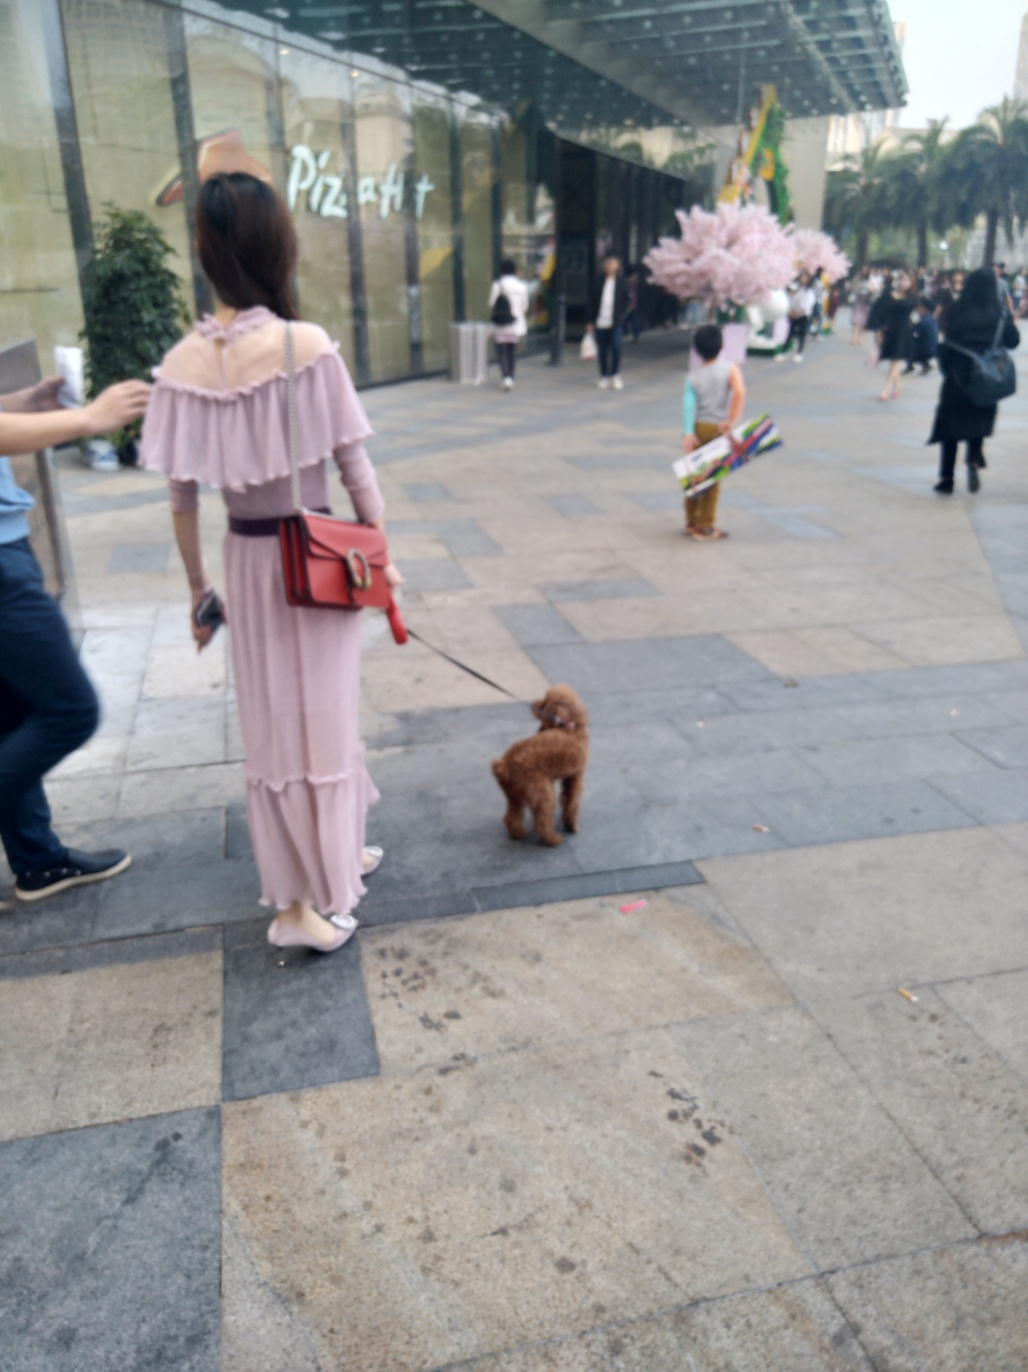What are the main subjects in this image?
A. Pedestrians, road, shopping mall
B. Animals, mountains, rivers
C. Buildings, trees, sky
D. Cars, bicycles, traffic lights The main subjects of the image are pedestrians and the urban environment. Featuring prominently is a pedestrian pathway lined with shops, including a notable pizza establishment. There is also a person wearing a pink garment and a child holding a colorful item. The correct answer, reflecting the visible elements, is option A. Pedestrians, road, shopping mall. 